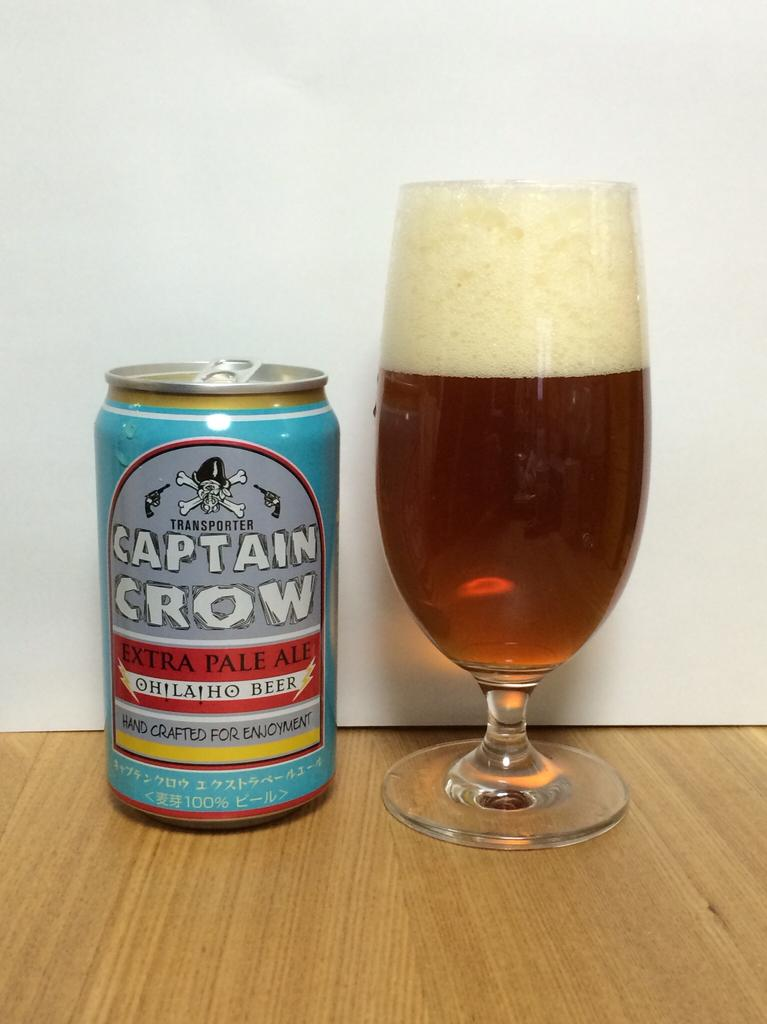Provide a one-sentence caption for the provided image. A can of Captain Crow sits next to a glass filled with liquid. 